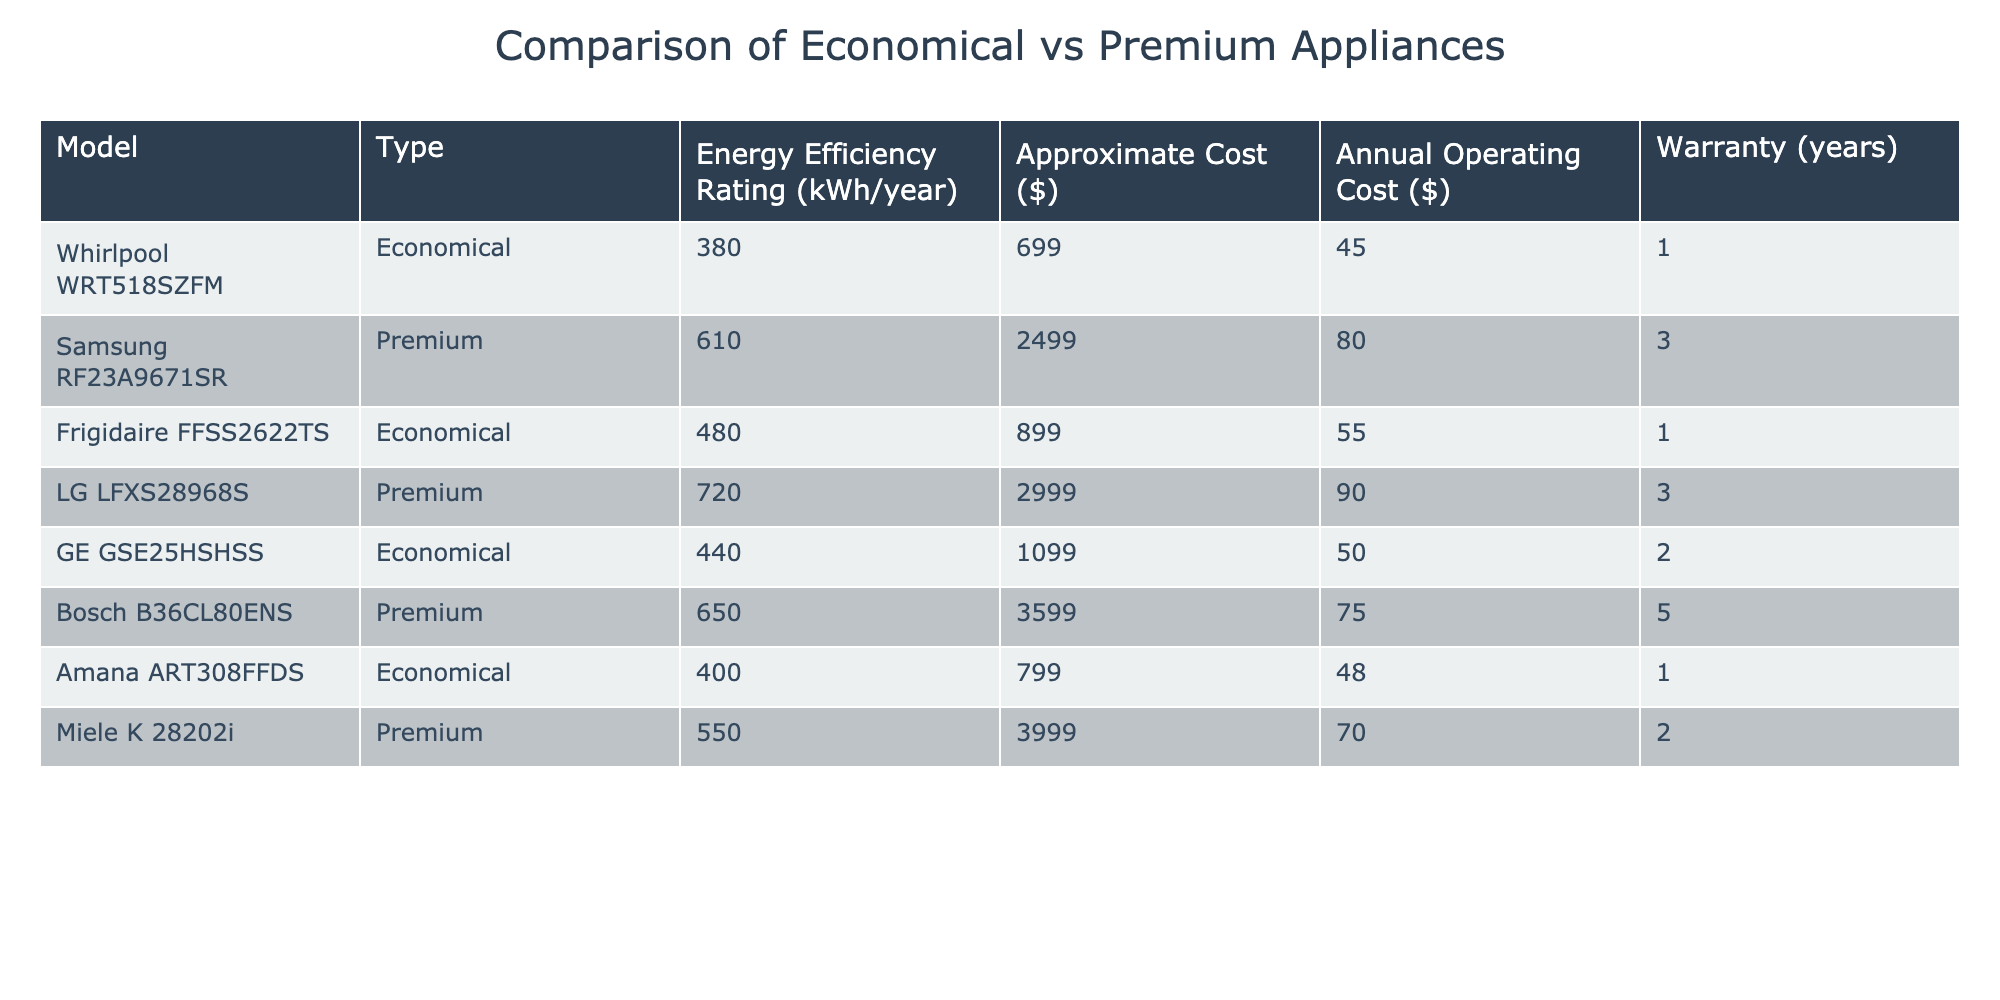What is the energy efficiency rating of the Whirlpool WRT518SZFM? The rating for the Whirlpool WRT518SZFM is directly listed in the table under the "Energy Efficiency Rating (kWh/year)" column. It shows a rating of 380 kWh/year.
Answer: 380 kWh/year What is the approximate cost of the LG LFXS28968S? The approximate cost for the LG LFXS28968S is stated in the "Approximate Cost ($)" column of the table, which indicates it costs $2999.
Answer: $2999 What is the difference in annual operating costs between the Frigidaire FFSS2622TS and the GE GSE25HSHSS? The annual operating cost of the Frigidaire FFSS2622TS is $55, while for the GE GSE25HSHSS it is $50. The difference is calculated as $55 - $50 = $5.
Answer: $5 Is the energy efficiency rating for the Amana ART308FFDS greater than that of the Bosch B36CL80ENS? The energy efficiency rating of the Amana ART308FFDS is 400 kWh/year, while Bosch B36CL80ENS is 650 kWh/year. Since 400 is less than 650, the statement is false.
Answer: No What is the average annual operating cost of the economical appliances listed? The annual operating costs for the economical appliances are $45, $55, $50, and $48. Summing these costs gives $45 + $55 + $50 + $48 = $198. Dividing by the number of appliances (4) results in an average of $198 / 4 = $49.5.
Answer: $49.5 Which model has the longest warranty among the premium appliances? The only models listed under premium appliances are Samsung RF23A9671SR, LG LFXS28968S, Bosch B36CL80ENS, and Miele K 28202i with warranties of 3, 3, 5, and 2 years respectively. The longest warranty is 5 years for the Bosch B36CL80ENS.
Answer: Bosch B36CL80ENS Is the approximate cost of the Frigidaire FFSS2622TS higher than $900? The approximate cost for the Frigidaire FFSS2622TS listed in the table is $899, which is not higher than $900. Therefore, the statement is false.
Answer: No What is the total energy efficiency rating for all the premium appliances? The energy efficiency ratings for the premium models are 610, 720, 650, and 550. Their total is calculated as 610 + 720 + 650 + 550 = 2630.
Answer: 2630 kWh/year What is the ratio of the approximate costs of the cheapest economical model to the most expensive premium model? The cheapest economical model is Whirlpool WRT518SZFM at $699 and the most expensive premium model is LG LFXS28968S at $2999. The ratio is calculated as 699:2999 or simplified, can be calculated as 699 / 2999 = 0.233.
Answer: 0.233 